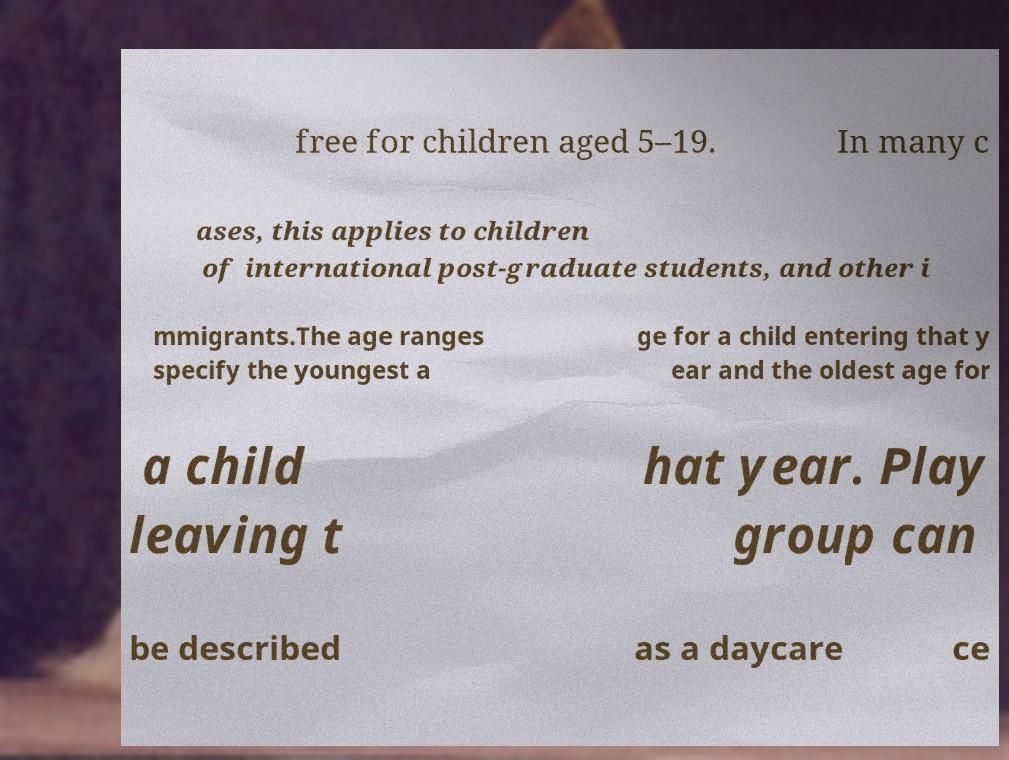For documentation purposes, I need the text within this image transcribed. Could you provide that? free for children aged 5–19. In many c ases, this applies to children of international post-graduate students, and other i mmigrants.The age ranges specify the youngest a ge for a child entering that y ear and the oldest age for a child leaving t hat year. Play group can be described as a daycare ce 